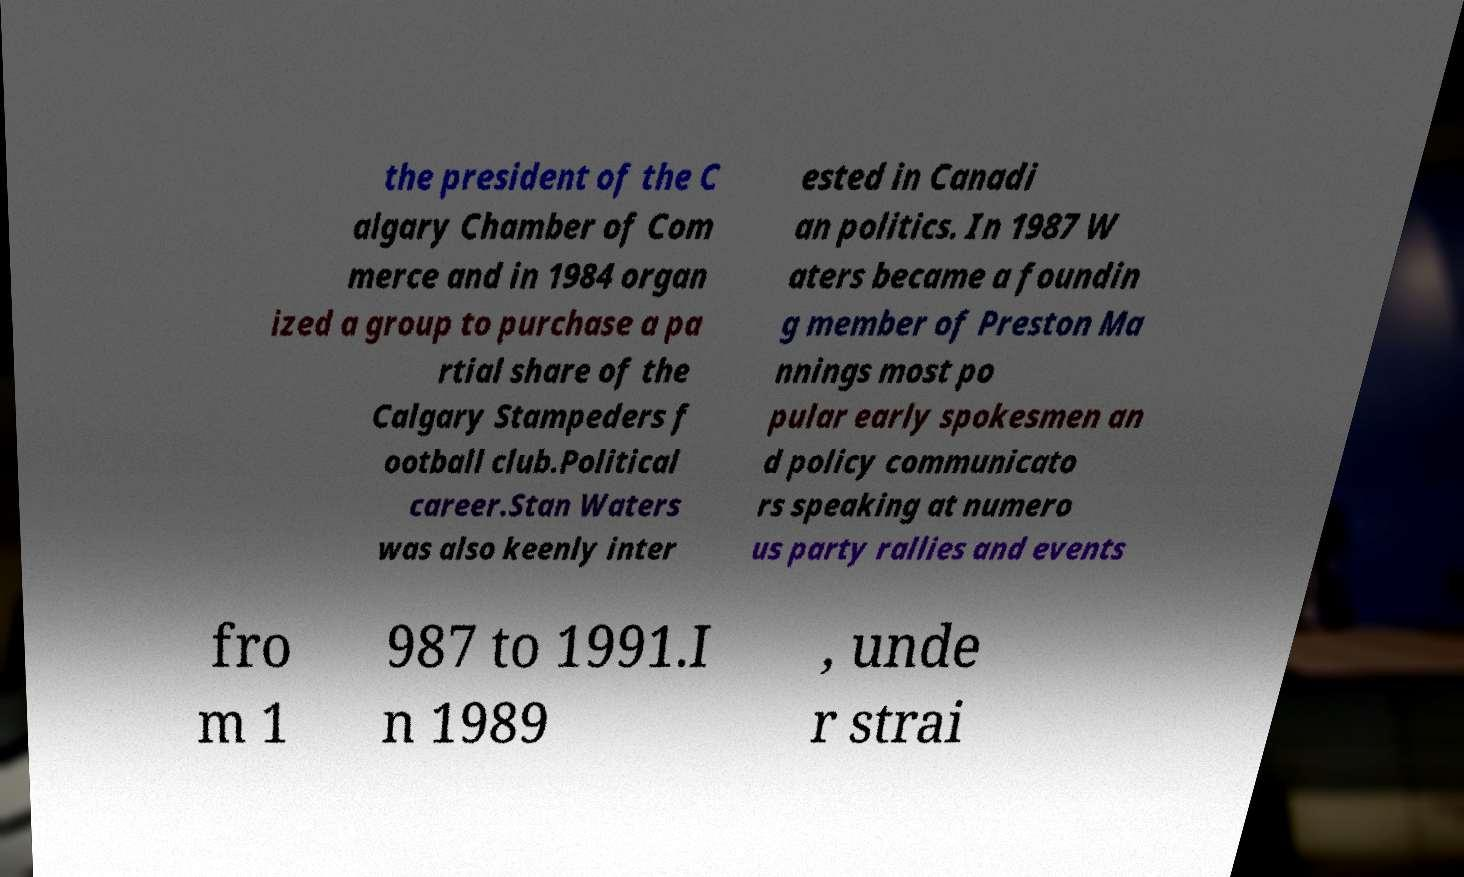Please identify and transcribe the text found in this image. the president of the C algary Chamber of Com merce and in 1984 organ ized a group to purchase a pa rtial share of the Calgary Stampeders f ootball club.Political career.Stan Waters was also keenly inter ested in Canadi an politics. In 1987 W aters became a foundin g member of Preston Ma nnings most po pular early spokesmen an d policy communicato rs speaking at numero us party rallies and events fro m 1 987 to 1991.I n 1989 , unde r strai 